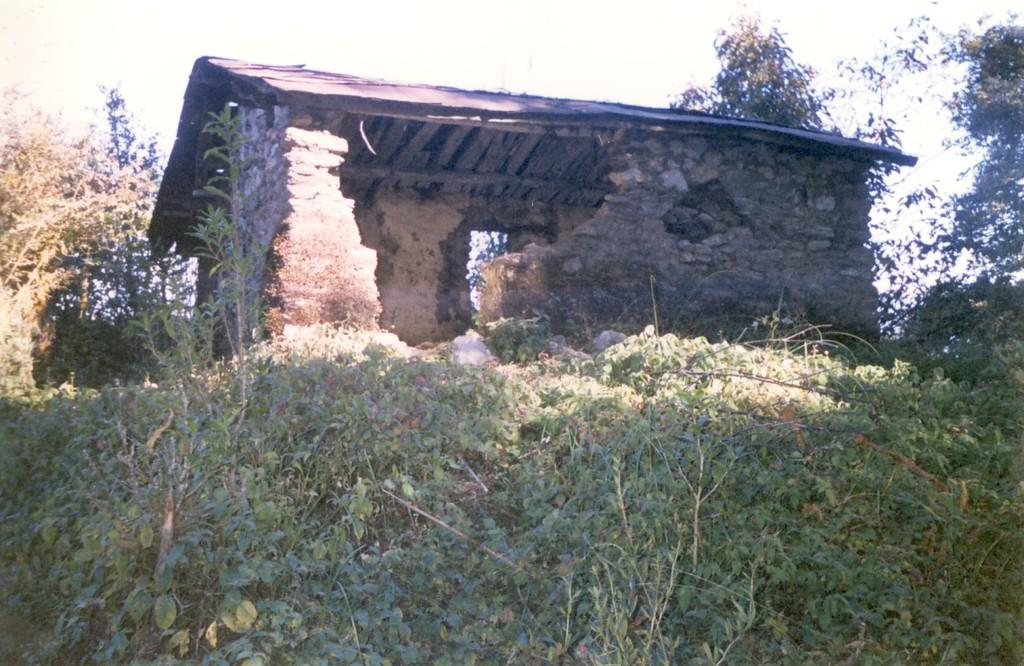What type of structure is present in the image? There is a ruin hut in the image. What can be seen on the ground around the hut? There is grass on the surface around the hut. Are there any other natural elements visible in the image? Yes, there are trees beside the hut. What type of cracker is being used to repair the hut in the image? There is no cracker present in the image, nor is there any indication of repair work being done on the hut. 